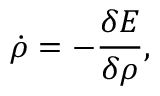Convert formula to latex. <formula><loc_0><loc_0><loc_500><loc_500>\dot { \rho } = - \frac { \delta E } { \delta \rho } ,</formula> 